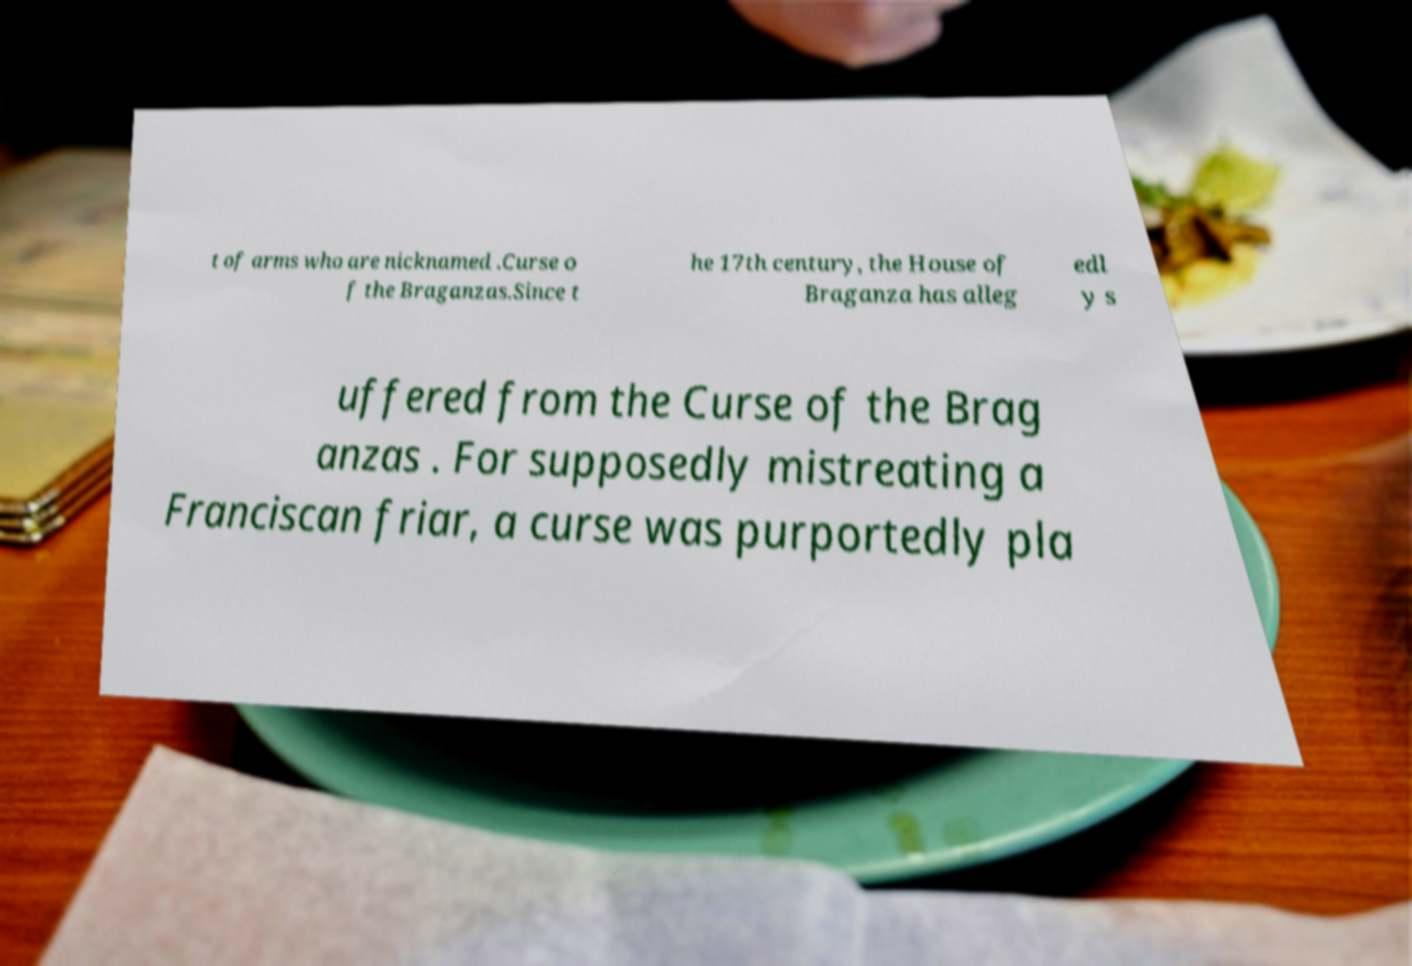What messages or text are displayed in this image? I need them in a readable, typed format. t of arms who are nicknamed .Curse o f the Braganzas.Since t he 17th century, the House of Braganza has alleg edl y s uffered from the Curse of the Brag anzas . For supposedly mistreating a Franciscan friar, a curse was purportedly pla 